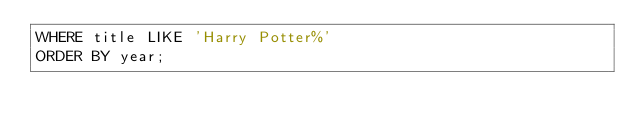Convert code to text. <code><loc_0><loc_0><loc_500><loc_500><_SQL_>WHERE title LIKE 'Harry Potter%'
ORDER BY year;</code> 